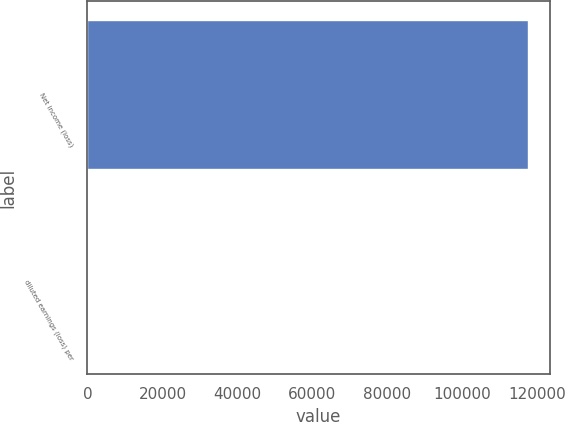Convert chart to OTSL. <chart><loc_0><loc_0><loc_500><loc_500><bar_chart><fcel>Net income (loss)<fcel>diluted earnings (loss) per<nl><fcel>117361<fcel>1.88<nl></chart> 